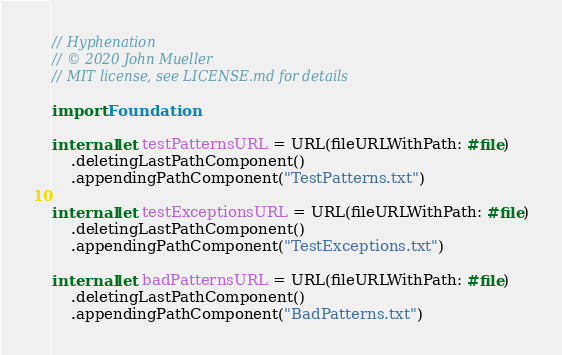Convert code to text. <code><loc_0><loc_0><loc_500><loc_500><_Swift_>// Hyphenation
// © 2020 John Mueller
// MIT license, see LICENSE.md for details

import Foundation

internal let testPatternsURL = URL(fileURLWithPath: #file)
    .deletingLastPathComponent()
    .appendingPathComponent("TestPatterns.txt")

internal let testExceptionsURL = URL(fileURLWithPath: #file)
    .deletingLastPathComponent()
    .appendingPathComponent("TestExceptions.txt")

internal let badPatternsURL = URL(fileURLWithPath: #file)
    .deletingLastPathComponent()
    .appendingPathComponent("BadPatterns.txt")
</code> 